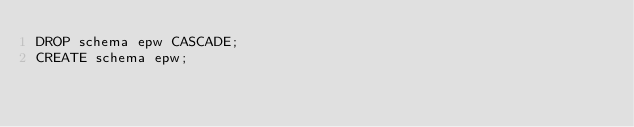Convert code to text. <code><loc_0><loc_0><loc_500><loc_500><_SQL_>DROP schema epw CASCADE;
CREATE schema epw;</code> 